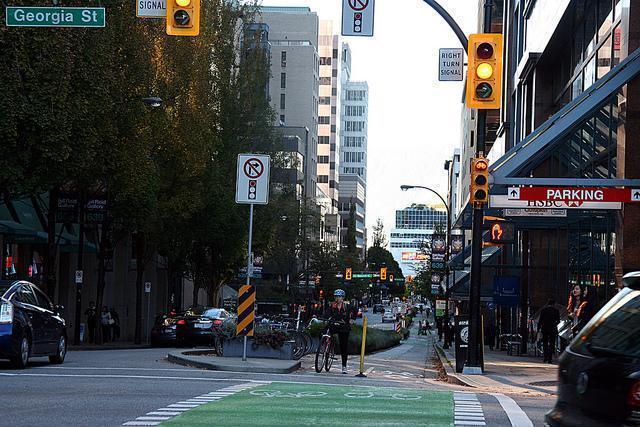What is the lane painted green for?
Make your selection and explain in format: 'Answer: answer
Rationale: rationale.'
Options: Minivans only, pedestrians only, bikes only, keep out. Answer: bikes only.
Rationale: It's the bike lane for cyclists. 